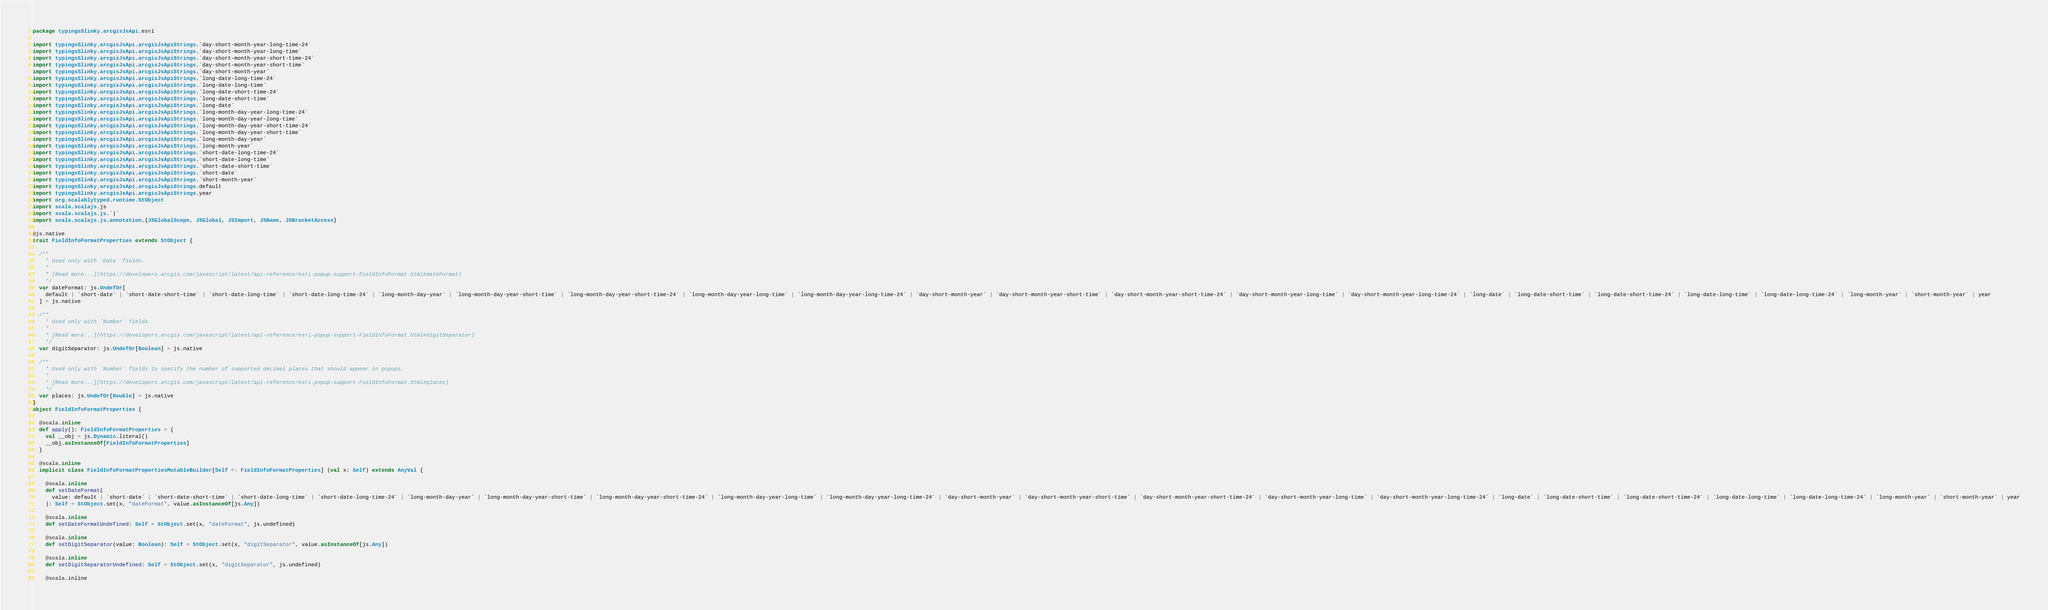Convert code to text. <code><loc_0><loc_0><loc_500><loc_500><_Scala_>package typingsSlinky.arcgisJsApi.esri

import typingsSlinky.arcgisJsApi.arcgisJsApiStrings.`day-short-month-year-long-time-24`
import typingsSlinky.arcgisJsApi.arcgisJsApiStrings.`day-short-month-year-long-time`
import typingsSlinky.arcgisJsApi.arcgisJsApiStrings.`day-short-month-year-short-time-24`
import typingsSlinky.arcgisJsApi.arcgisJsApiStrings.`day-short-month-year-short-time`
import typingsSlinky.arcgisJsApi.arcgisJsApiStrings.`day-short-month-year`
import typingsSlinky.arcgisJsApi.arcgisJsApiStrings.`long-date-long-time-24`
import typingsSlinky.arcgisJsApi.arcgisJsApiStrings.`long-date-long-time`
import typingsSlinky.arcgisJsApi.arcgisJsApiStrings.`long-date-short-time-24`
import typingsSlinky.arcgisJsApi.arcgisJsApiStrings.`long-date-short-time`
import typingsSlinky.arcgisJsApi.arcgisJsApiStrings.`long-date`
import typingsSlinky.arcgisJsApi.arcgisJsApiStrings.`long-month-day-year-long-time-24`
import typingsSlinky.arcgisJsApi.arcgisJsApiStrings.`long-month-day-year-long-time`
import typingsSlinky.arcgisJsApi.arcgisJsApiStrings.`long-month-day-year-short-time-24`
import typingsSlinky.arcgisJsApi.arcgisJsApiStrings.`long-month-day-year-short-time`
import typingsSlinky.arcgisJsApi.arcgisJsApiStrings.`long-month-day-year`
import typingsSlinky.arcgisJsApi.arcgisJsApiStrings.`long-month-year`
import typingsSlinky.arcgisJsApi.arcgisJsApiStrings.`short-date-long-time-24`
import typingsSlinky.arcgisJsApi.arcgisJsApiStrings.`short-date-long-time`
import typingsSlinky.arcgisJsApi.arcgisJsApiStrings.`short-date-short-time`
import typingsSlinky.arcgisJsApi.arcgisJsApiStrings.`short-date`
import typingsSlinky.arcgisJsApi.arcgisJsApiStrings.`short-month-year`
import typingsSlinky.arcgisJsApi.arcgisJsApiStrings.default
import typingsSlinky.arcgisJsApi.arcgisJsApiStrings.year
import org.scalablytyped.runtime.StObject
import scala.scalajs.js
import scala.scalajs.js.`|`
import scala.scalajs.js.annotation.{JSGlobalScope, JSGlobal, JSImport, JSName, JSBracketAccess}

@js.native
trait FieldInfoFormatProperties extends StObject {
  
  /**
    * Used only with `Date` fields.
    *
    * [Read more...](https://developers.arcgis.com/javascript/latest/api-reference/esri-popup-support-FieldInfoFormat.html#dateFormat)
    */
  var dateFormat: js.UndefOr[
    default | `short-date` | `short-date-short-time` | `short-date-long-time` | `short-date-long-time-24` | `long-month-day-year` | `long-month-day-year-short-time` | `long-month-day-year-short-time-24` | `long-month-day-year-long-time` | `long-month-day-year-long-time-24` | `day-short-month-year` | `day-short-month-year-short-time` | `day-short-month-year-short-time-24` | `day-short-month-year-long-time` | `day-short-month-year-long-time-24` | `long-date` | `long-date-short-time` | `long-date-short-time-24` | `long-date-long-time` | `long-date-long-time-24` | `long-month-year` | `short-month-year` | year
  ] = js.native
  
  /**
    * Used only with `Number` fields.
    *
    * [Read more...](https://developers.arcgis.com/javascript/latest/api-reference/esri-popup-support-FieldInfoFormat.html#digitSeparator)
    */
  var digitSeparator: js.UndefOr[Boolean] = js.native
  
  /**
    * Used only with `Number` fields to specify the number of supported decimal places that should appear in popups.
    *
    * [Read more...](https://developers.arcgis.com/javascript/latest/api-reference/esri-popup-support-FieldInfoFormat.html#places)
    */
  var places: js.UndefOr[Double] = js.native
}
object FieldInfoFormatProperties {
  
  @scala.inline
  def apply(): FieldInfoFormatProperties = {
    val __obj = js.Dynamic.literal()
    __obj.asInstanceOf[FieldInfoFormatProperties]
  }
  
  @scala.inline
  implicit class FieldInfoFormatPropertiesMutableBuilder[Self <: FieldInfoFormatProperties] (val x: Self) extends AnyVal {
    
    @scala.inline
    def setDateFormat(
      value: default | `short-date` | `short-date-short-time` | `short-date-long-time` | `short-date-long-time-24` | `long-month-day-year` | `long-month-day-year-short-time` | `long-month-day-year-short-time-24` | `long-month-day-year-long-time` | `long-month-day-year-long-time-24` | `day-short-month-year` | `day-short-month-year-short-time` | `day-short-month-year-short-time-24` | `day-short-month-year-long-time` | `day-short-month-year-long-time-24` | `long-date` | `long-date-short-time` | `long-date-short-time-24` | `long-date-long-time` | `long-date-long-time-24` | `long-month-year` | `short-month-year` | year
    ): Self = StObject.set(x, "dateFormat", value.asInstanceOf[js.Any])
    
    @scala.inline
    def setDateFormatUndefined: Self = StObject.set(x, "dateFormat", js.undefined)
    
    @scala.inline
    def setDigitSeparator(value: Boolean): Self = StObject.set(x, "digitSeparator", value.asInstanceOf[js.Any])
    
    @scala.inline
    def setDigitSeparatorUndefined: Self = StObject.set(x, "digitSeparator", js.undefined)
    
    @scala.inline</code> 